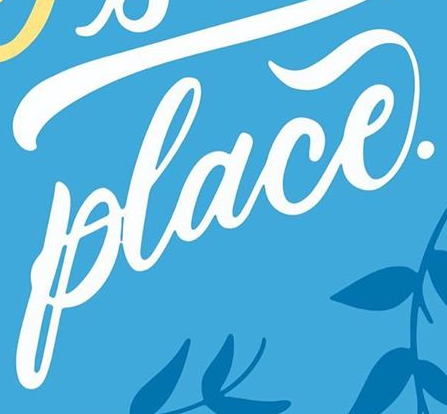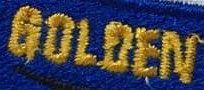What text appears in these images from left to right, separated by a semicolon? place.; GOLOEN 